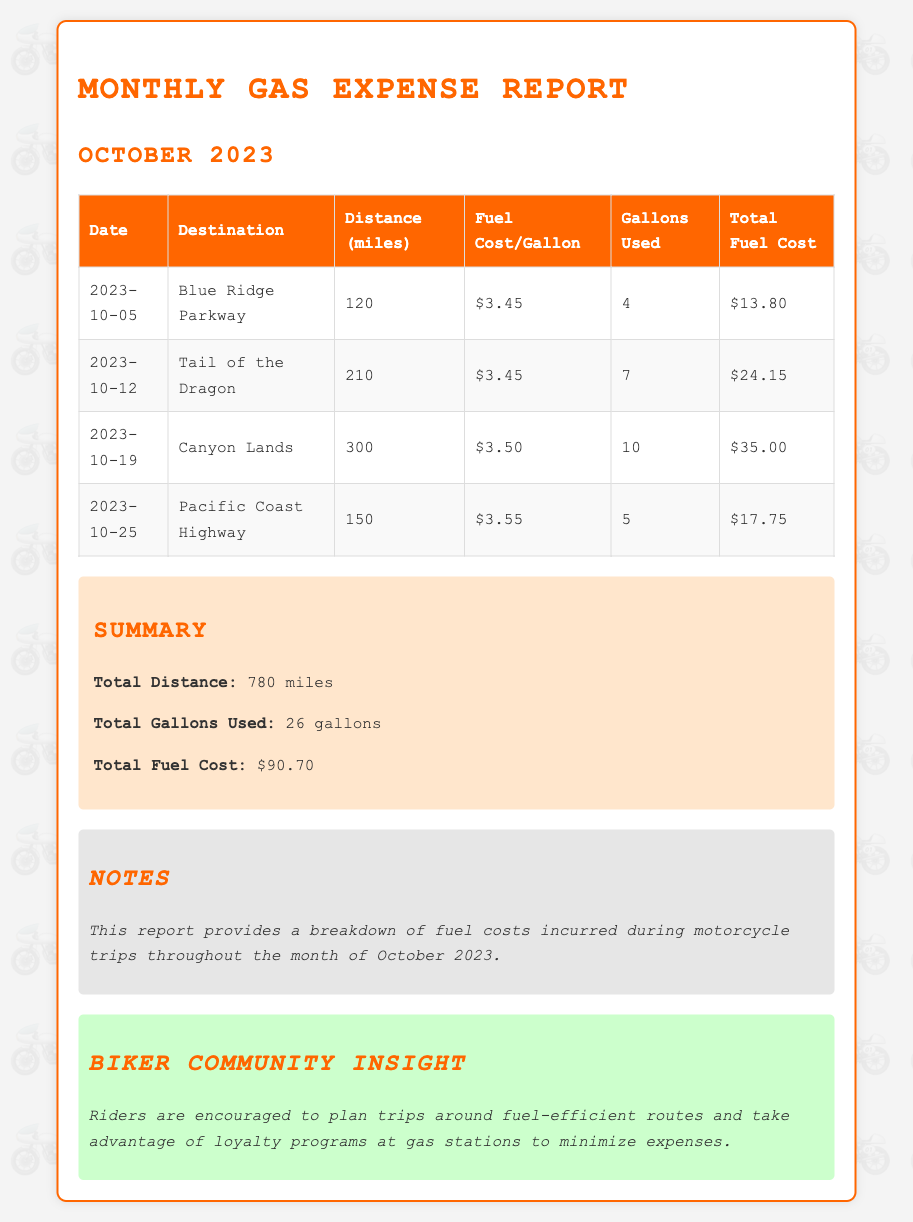What is the date of the trip to Canyon Lands? The date for the Canyon Lands trip is listed as 2023-10-19.
Answer: 2023-10-19 What was the total distance traveled on motorcycle trips? The total distance is provided in the summary section, which states it was 780 miles for the month.
Answer: 780 miles How many gallons were used for the trip to the Tail of the Dragon? The gallons used for the Tail of the Dragon trip are shown as 7 gallons in the table.
Answer: 7 gallons What was the fuel cost per gallon for the trip to the Pacific Coast Highway? The fuel cost per gallon for that trip is indicated as $3.55 in the corresponding row of the table.
Answer: $3.55 What is the total fuel cost for all trips combined? The summary section indicates that the total fuel cost across all trips was $90.70.
Answer: $90.70 Which destination had the largest distance traveled? The trip with the largest distance is Canyon Lands, which was 300 miles.
Answer: Canyon Lands How many trips were taken in October 2023? The document lists four trips taken in October 2023, as shown in the table.
Answer: 4 trips What insight is provided for the biker community? The document suggests that riders take advantage of loyalty programs at gas stations.
Answer: Loyalty programs at gas stations What was the total gallons used across all trips? The summary states that the total gallons used for all trips was 26 gallons.
Answer: 26 gallons 